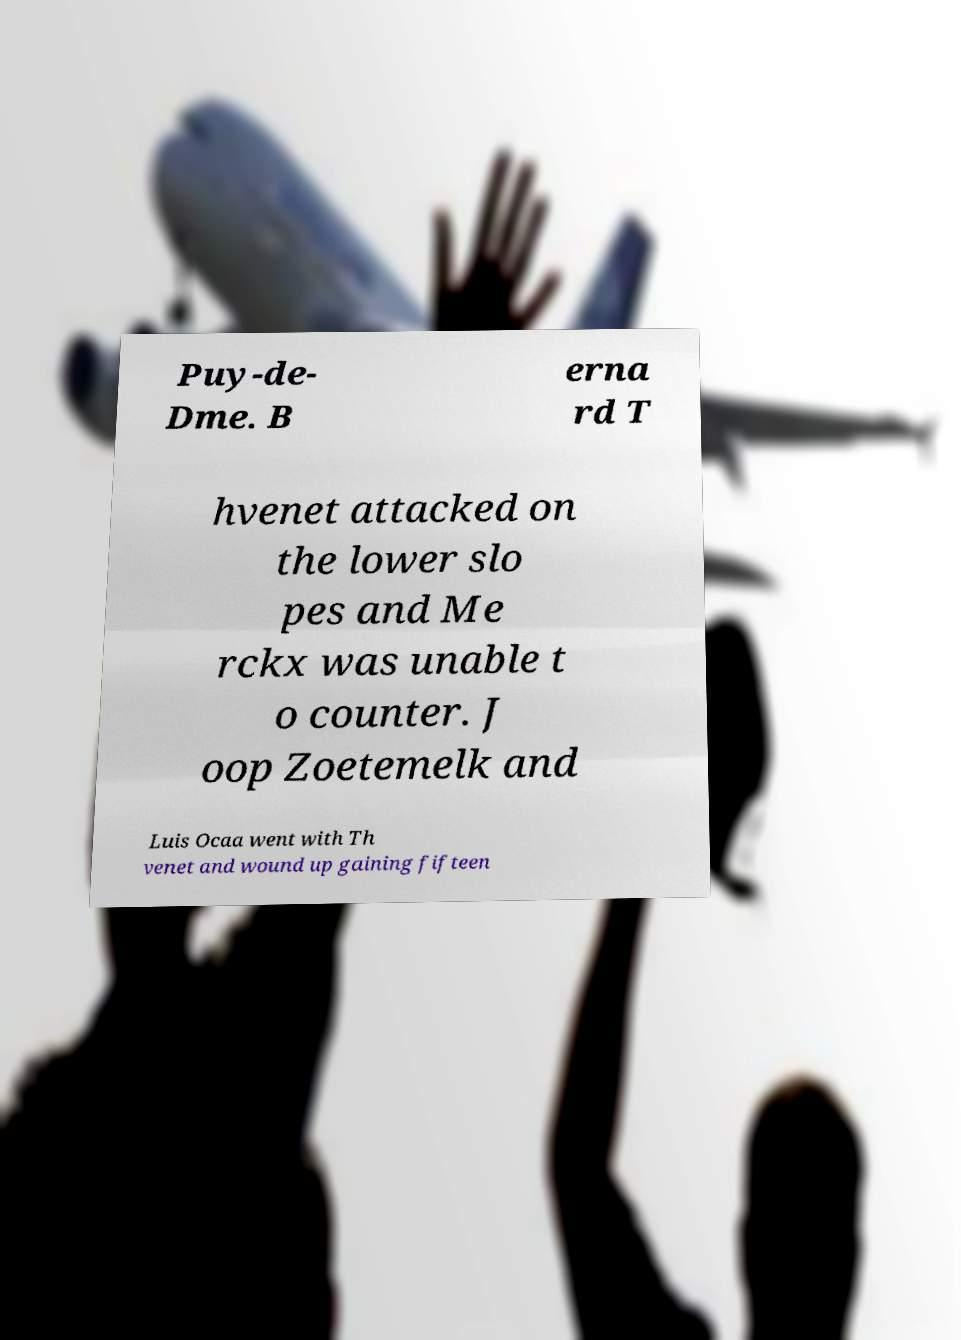Could you assist in decoding the text presented in this image and type it out clearly? Puy-de- Dme. B erna rd T hvenet attacked on the lower slo pes and Me rckx was unable t o counter. J oop Zoetemelk and Luis Ocaa went with Th venet and wound up gaining fifteen 